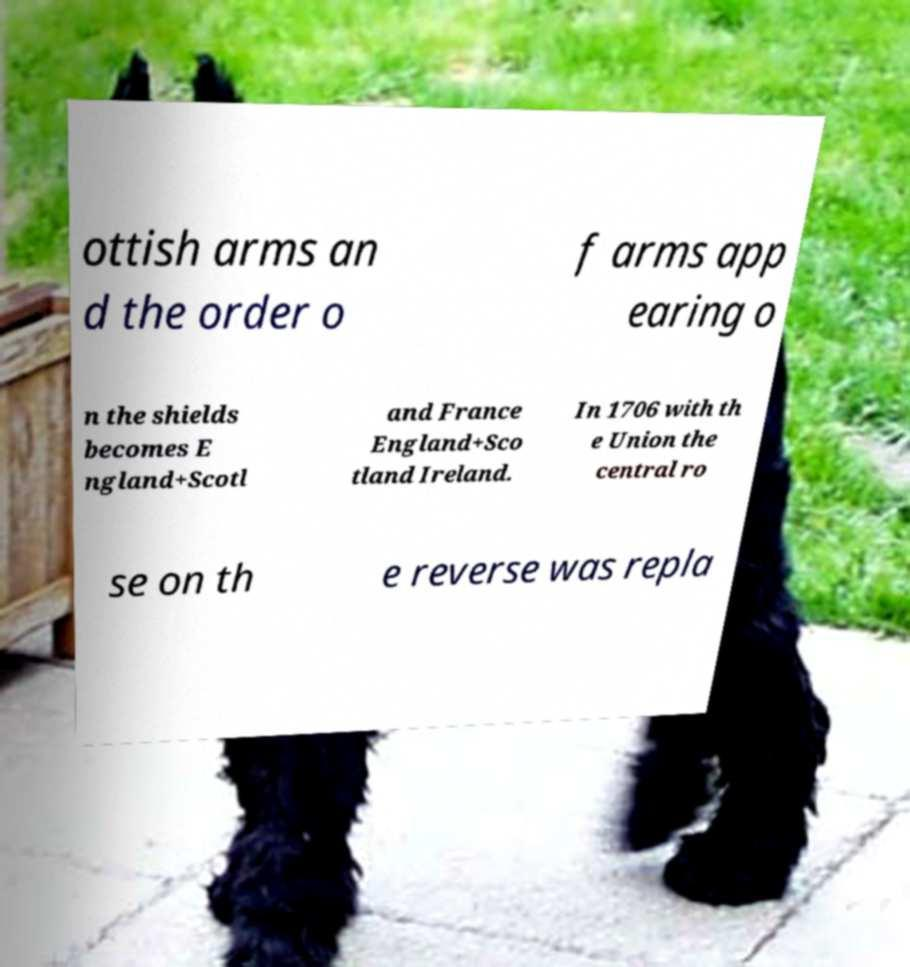I need the written content from this picture converted into text. Can you do that? ottish arms an d the order o f arms app earing o n the shields becomes E ngland+Scotl and France England+Sco tland Ireland. In 1706 with th e Union the central ro se on th e reverse was repla 